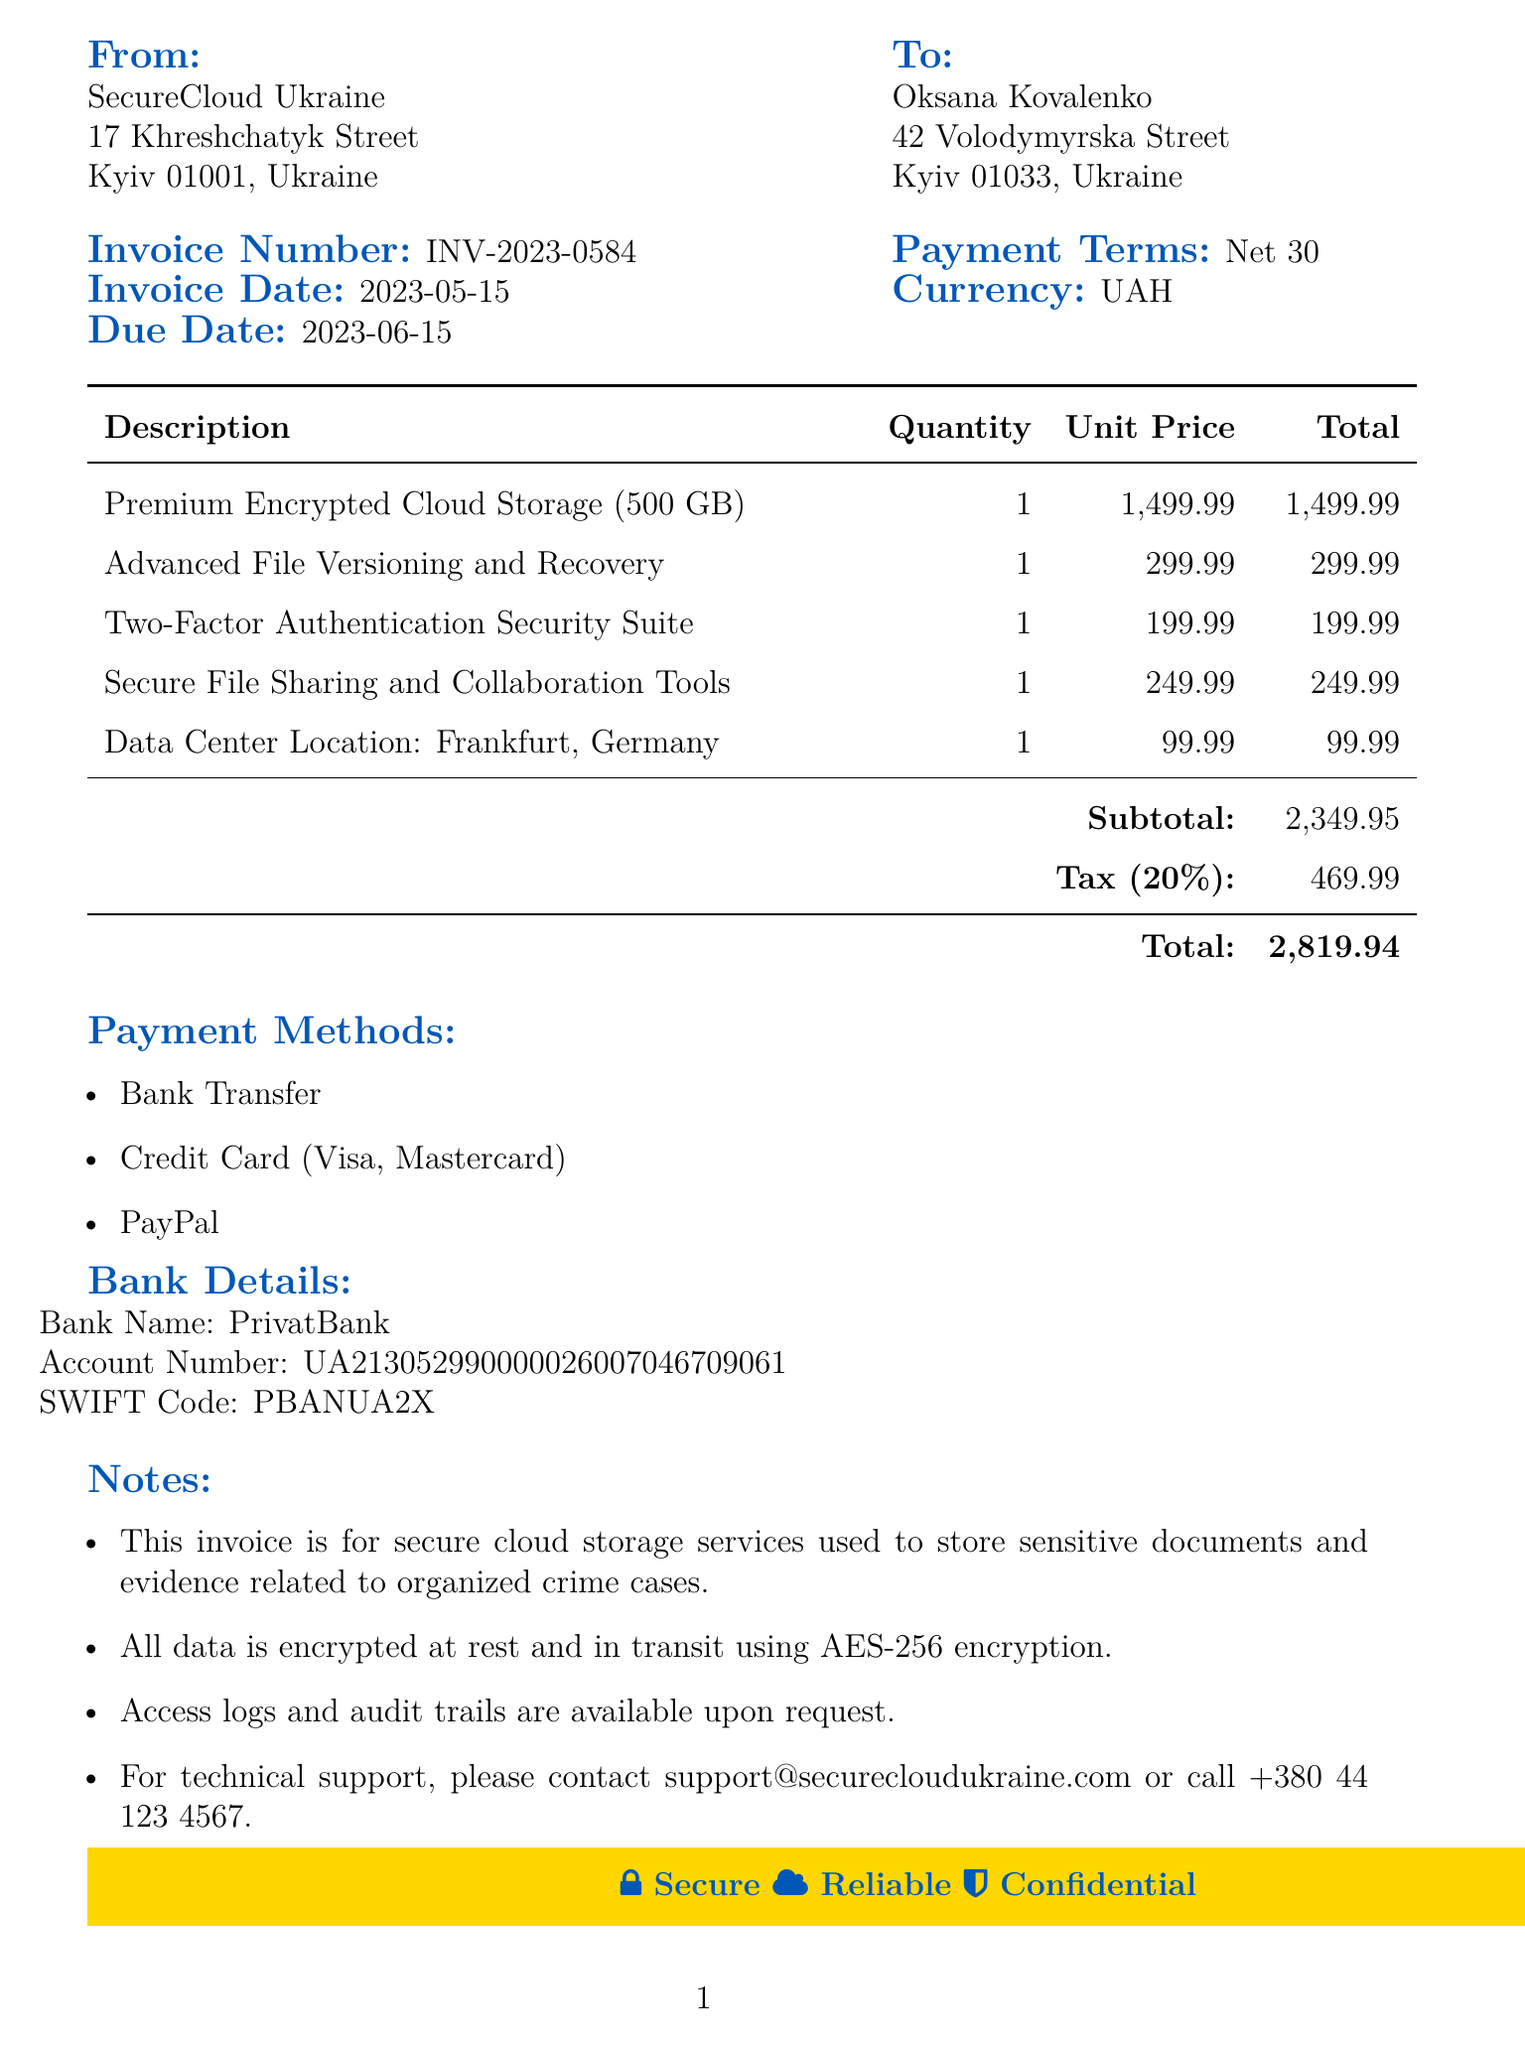What is the invoice number? The invoice number is specifically listed in the document, allowing for easy reference to this particular billing statement.
Answer: INV-2023-0584 Who is the customer? The customer's name is provided at the beginning of the document, which is important for identifying the party being billed.
Answer: Oksana Kovalenko What is the total amount due? The total amount due is calculated by adding the subtotal and tax amount, which are highlighted for quick reference.
Answer: 2819.94 What is the tax rate? The tax rate is indicated in the invoice, showcasing the percentage applied to the subtotal to determine the tax amount.
Answer: 20% What services are included? The services provided in the invoice can be found in the itemized list, detailing the specific offerings for the billing period.
Answer: Premium Encrypted Cloud Storage, Advanced File Versioning and Recovery, Two-Factor Authentication Security Suite, Secure File Sharing and Collaboration Tools, Data Center Location When is the payment due? The due date is clearly stated in the invoice, which informs the customer when payment must be made to avoid penalties.
Answer: 2023-06-15 What payment methods are accepted? The invoice outlines various payment options available to the customer, which is essential for completing the transaction.
Answer: Bank Transfer, Credit Card (Visa, Mastercard), PayPal What encryption is used for data security? The invoice notes refer to specific encryption standards used to protect sensitive information, which is crucial for secure services.
Answer: AES-256 What is the subtotal amount? The subtotal amount reflects the total of all charges before taxes and is an essential figure in understanding the overall costs.
Answer: 2349.95 